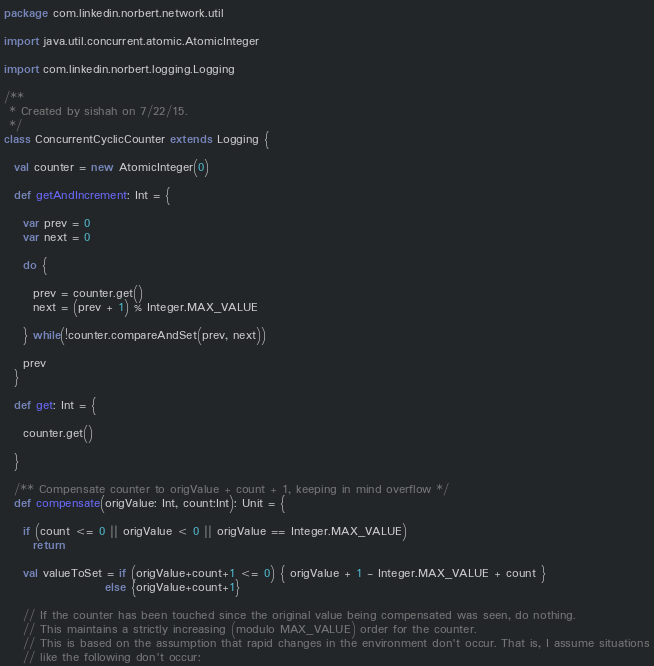Convert code to text. <code><loc_0><loc_0><loc_500><loc_500><_Scala_>package com.linkedin.norbert.network.util

import java.util.concurrent.atomic.AtomicInteger

import com.linkedin.norbert.logging.Logging

/**
 * Created by sishah on 7/22/15.
 */
class ConcurrentCyclicCounter extends Logging {

  val counter = new AtomicInteger(0)

  def getAndIncrement: Int = {

    var prev = 0
    var next = 0

    do {

      prev = counter.get()
      next = (prev + 1) % Integer.MAX_VALUE

    } while(!counter.compareAndSet(prev, next))

    prev
  }

  def get: Int = {

    counter.get()

  }

  /** Compensate counter to origValue + count + 1, keeping in mind overflow */
  def compensate(origValue: Int, count:Int): Unit = {

    if (count <= 0 || origValue < 0 || origValue == Integer.MAX_VALUE)
      return

    val valueToSet = if (origValue+count+1 <= 0) { origValue + 1 - Integer.MAX_VALUE + count }
                     else {origValue+count+1}

    // If the counter has been touched since the original value being compensated was seen, do nothing.
    // This maintains a strictly increasing (modulo MAX_VALUE) order for the counter.
    // This is based on the assumption that rapid changes in the environment don't occur. That is, I assume situations
    // like the following don't occur:</code> 